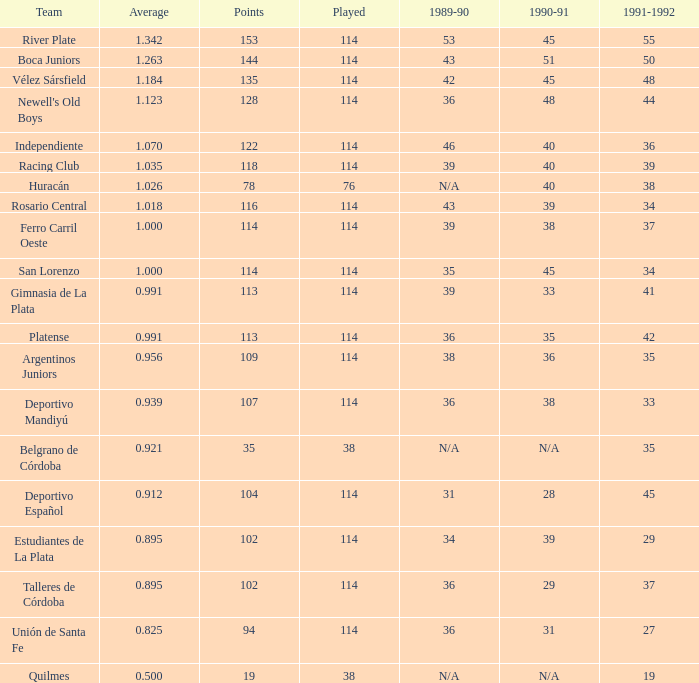How much Average has a 1989-90 of 36, and a Team of talleres de córdoba, and a Played smaller than 114? 0.0. 